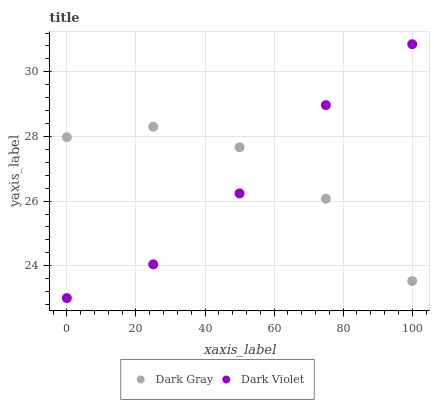Does Dark Violet have the minimum area under the curve?
Answer yes or no. Yes. Does Dark Gray have the maximum area under the curve?
Answer yes or no. Yes. Does Dark Violet have the maximum area under the curve?
Answer yes or no. No. Is Dark Violet the smoothest?
Answer yes or no. Yes. Is Dark Gray the roughest?
Answer yes or no. Yes. Is Dark Violet the roughest?
Answer yes or no. No. Does Dark Violet have the lowest value?
Answer yes or no. Yes. Does Dark Violet have the highest value?
Answer yes or no. Yes. Does Dark Violet intersect Dark Gray?
Answer yes or no. Yes. Is Dark Violet less than Dark Gray?
Answer yes or no. No. Is Dark Violet greater than Dark Gray?
Answer yes or no. No. 